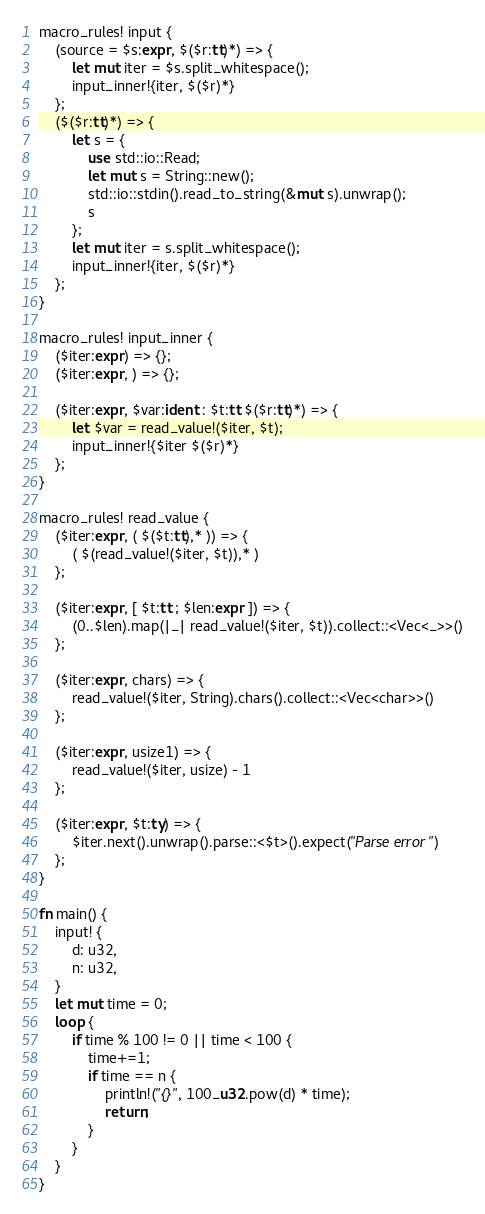Convert code to text. <code><loc_0><loc_0><loc_500><loc_500><_Rust_>macro_rules! input {
    (source = $s:expr, $($r:tt)*) => {
        let mut iter = $s.split_whitespace();
        input_inner!{iter, $($r)*}
    };
    ($($r:tt)*) => {
        let s = {
            use std::io::Read;
            let mut s = String::new();
            std::io::stdin().read_to_string(&mut s).unwrap();
            s
        };
        let mut iter = s.split_whitespace();
        input_inner!{iter, $($r)*}
    };
}

macro_rules! input_inner {
    ($iter:expr) => {};
    ($iter:expr, ) => {};

    ($iter:expr, $var:ident : $t:tt $($r:tt)*) => {
        let $var = read_value!($iter, $t);
        input_inner!{$iter $($r)*}
    };
}

macro_rules! read_value {
    ($iter:expr, ( $($t:tt),* )) => {
        ( $(read_value!($iter, $t)),* )
    };

    ($iter:expr, [ $t:tt ; $len:expr ]) => {
        (0..$len).map(|_| read_value!($iter, $t)).collect::<Vec<_>>()
    };

    ($iter:expr, chars) => {
        read_value!($iter, String).chars().collect::<Vec<char>>()
    };

    ($iter:expr, usize1) => {
        read_value!($iter, usize) - 1
    };

    ($iter:expr, $t:ty) => {
        $iter.next().unwrap().parse::<$t>().expect("Parse error")
    };
}

fn main() {
    input! {
        d: u32,
        n: u32,
    }
    let mut time = 0;
    loop {
        if time % 100 != 0 || time < 100 {
            time+=1;
            if time == n {
                println!("{}", 100_u32.pow(d) * time);
                return;
            }
        }
    }
}
</code> 